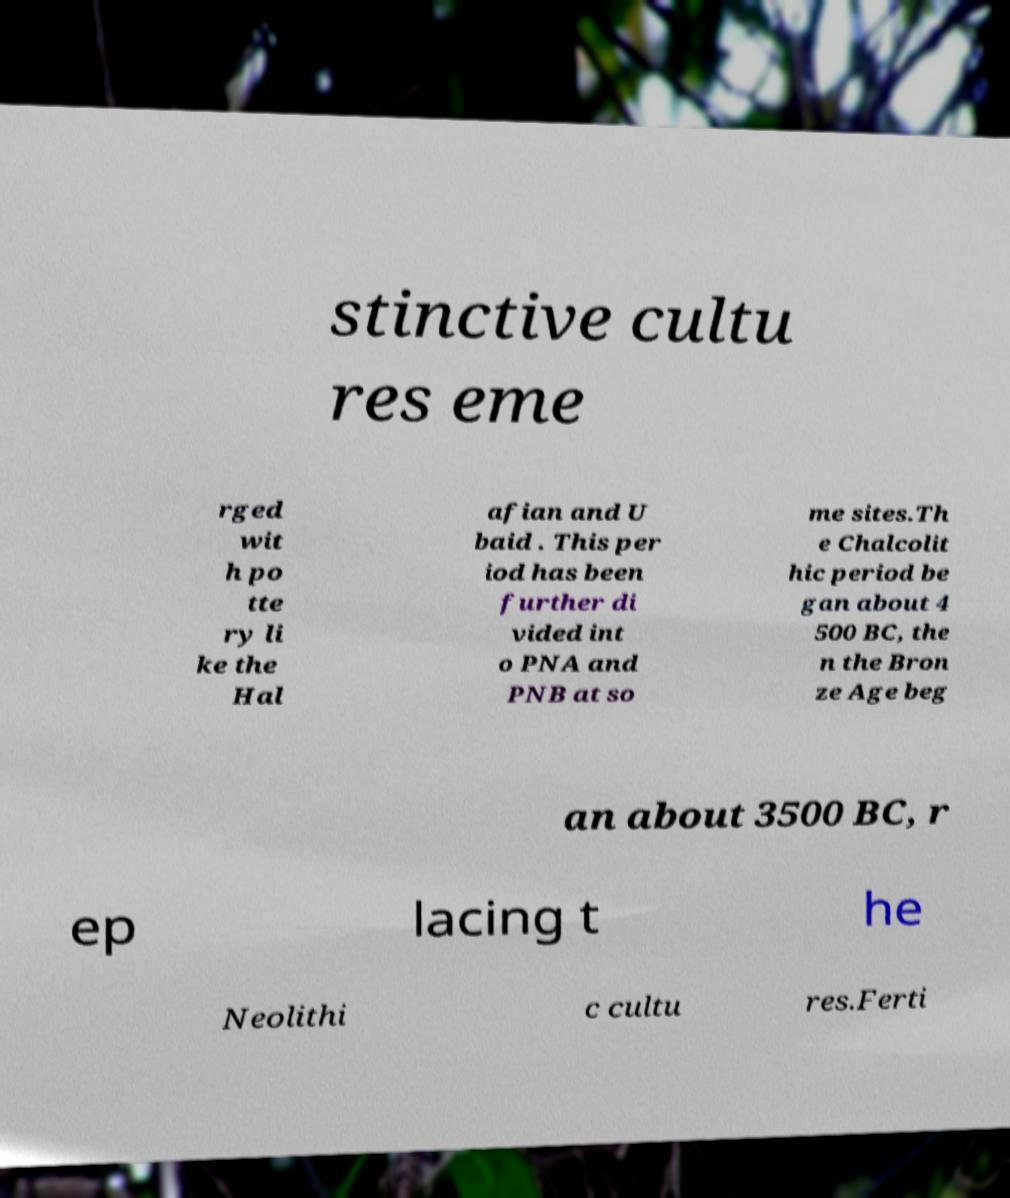What messages or text are displayed in this image? I need them in a readable, typed format. stinctive cultu res eme rged wit h po tte ry li ke the Hal afian and U baid . This per iod has been further di vided int o PNA and PNB at so me sites.Th e Chalcolit hic period be gan about 4 500 BC, the n the Bron ze Age beg an about 3500 BC, r ep lacing t he Neolithi c cultu res.Ferti 